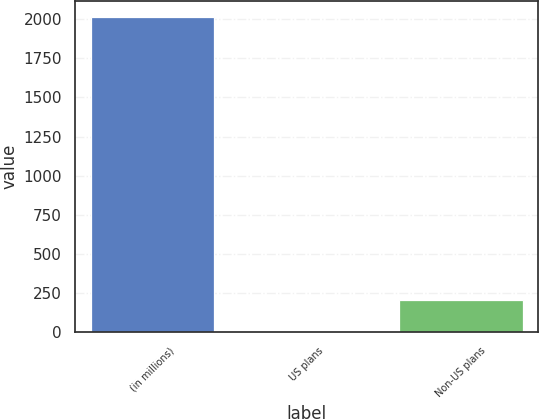Convert chart to OTSL. <chart><loc_0><loc_0><loc_500><loc_500><bar_chart><fcel>(in millions)<fcel>US plans<fcel>Non-US plans<nl><fcel>2015<fcel>6<fcel>206.9<nl></chart> 